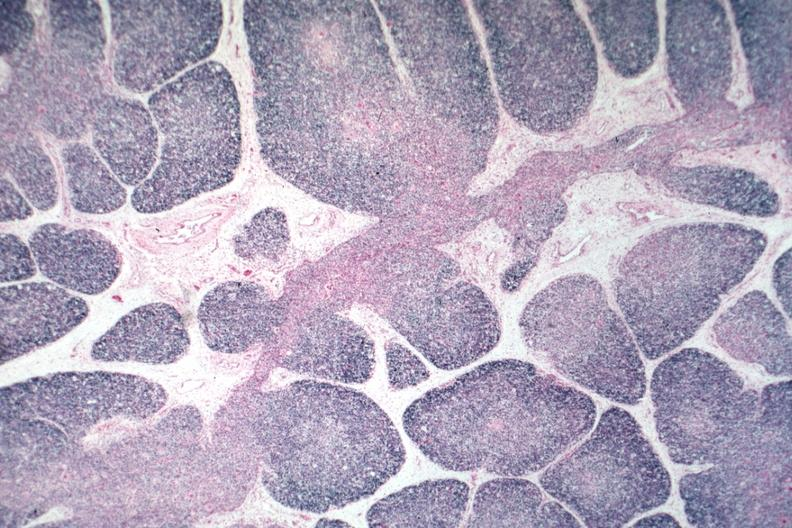what is present?
Answer the question using a single word or phrase. Normal immature infant 